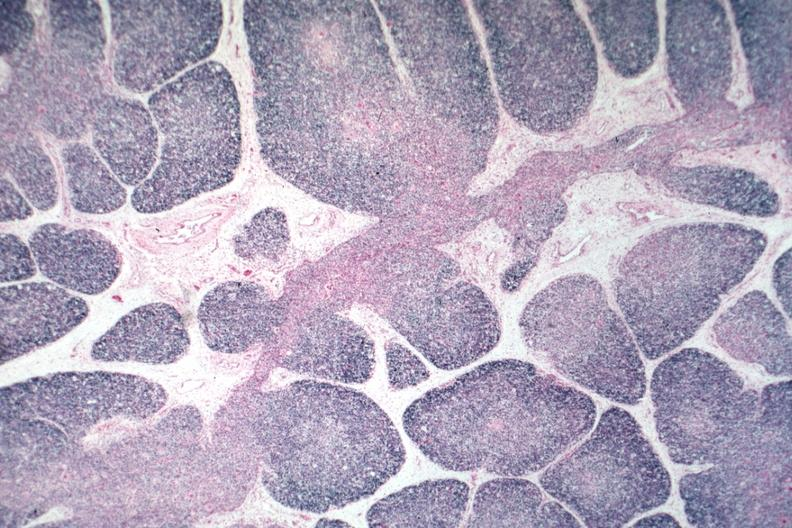what is present?
Answer the question using a single word or phrase. Normal immature infant 